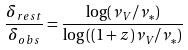<formula> <loc_0><loc_0><loc_500><loc_500>\frac { \delta _ { r e s t } } { \delta _ { o b s } } = \frac { \log ( \nu _ { V } / \nu _ { * } ) } { \log \left ( ( 1 + z ) \nu _ { V } / \nu _ { * } \right ) }</formula> 